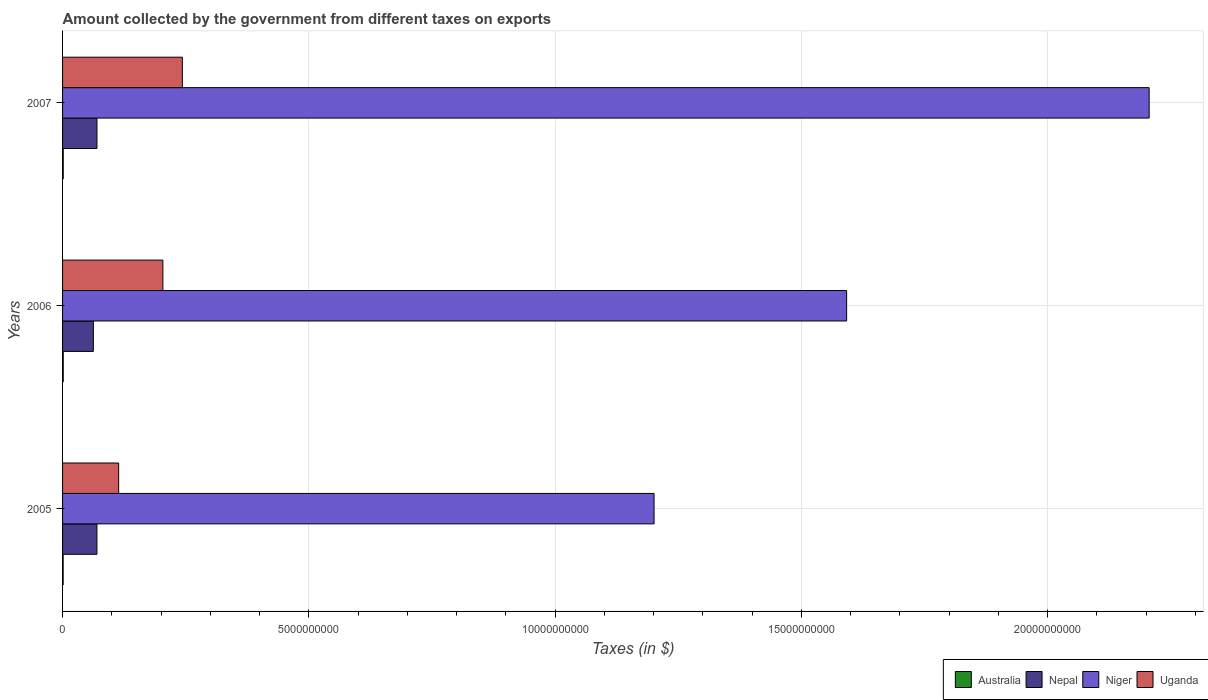How many different coloured bars are there?
Provide a short and direct response. 4. How many groups of bars are there?
Your response must be concise. 3. Are the number of bars per tick equal to the number of legend labels?
Keep it short and to the point. Yes. How many bars are there on the 3rd tick from the top?
Your answer should be compact. 4. How many bars are there on the 2nd tick from the bottom?
Provide a short and direct response. 4. What is the label of the 2nd group of bars from the top?
Your answer should be very brief. 2006. In how many cases, is the number of bars for a given year not equal to the number of legend labels?
Keep it short and to the point. 0. What is the amount collected by the government from taxes on exports in Uganda in 2007?
Offer a very short reply. 2.43e+09. Across all years, what is the maximum amount collected by the government from taxes on exports in Niger?
Your answer should be very brief. 2.21e+1. Across all years, what is the minimum amount collected by the government from taxes on exports in Nepal?
Your response must be concise. 6.25e+08. In which year was the amount collected by the government from taxes on exports in Nepal minimum?
Offer a terse response. 2006. What is the total amount collected by the government from taxes on exports in Australia in the graph?
Your response must be concise. 4.00e+07. What is the difference between the amount collected by the government from taxes on exports in Australia in 2006 and the amount collected by the government from taxes on exports in Niger in 2007?
Offer a very short reply. -2.20e+1. What is the average amount collected by the government from taxes on exports in Nepal per year?
Your answer should be very brief. 6.74e+08. In the year 2007, what is the difference between the amount collected by the government from taxes on exports in Uganda and amount collected by the government from taxes on exports in Niger?
Keep it short and to the point. -1.96e+1. What is the ratio of the amount collected by the government from taxes on exports in Nepal in 2005 to that in 2006?
Provide a short and direct response. 1.12. Is the amount collected by the government from taxes on exports in Australia in 2006 less than that in 2007?
Your answer should be compact. No. What is the difference between the highest and the second highest amount collected by the government from taxes on exports in Niger?
Keep it short and to the point. 6.14e+09. Is it the case that in every year, the sum of the amount collected by the government from taxes on exports in Nepal and amount collected by the government from taxes on exports in Australia is greater than the sum of amount collected by the government from taxes on exports in Niger and amount collected by the government from taxes on exports in Uganda?
Keep it short and to the point. No. What does the 1st bar from the bottom in 2007 represents?
Your answer should be compact. Australia. Are all the bars in the graph horizontal?
Your response must be concise. Yes. How many years are there in the graph?
Your response must be concise. 3. Are the values on the major ticks of X-axis written in scientific E-notation?
Keep it short and to the point. No. Does the graph contain any zero values?
Provide a succinct answer. No. Where does the legend appear in the graph?
Your answer should be very brief. Bottom right. What is the title of the graph?
Keep it short and to the point. Amount collected by the government from different taxes on exports. What is the label or title of the X-axis?
Provide a succinct answer. Taxes (in $). What is the Taxes (in $) in Australia in 2005?
Ensure brevity in your answer.  1.20e+07. What is the Taxes (in $) in Nepal in 2005?
Provide a short and direct response. 6.98e+08. What is the Taxes (in $) of Niger in 2005?
Provide a short and direct response. 1.20e+1. What is the Taxes (in $) in Uganda in 2005?
Offer a terse response. 1.14e+09. What is the Taxes (in $) of Australia in 2006?
Your response must be concise. 1.40e+07. What is the Taxes (in $) of Nepal in 2006?
Your answer should be very brief. 6.25e+08. What is the Taxes (in $) in Niger in 2006?
Your answer should be compact. 1.59e+1. What is the Taxes (in $) of Uganda in 2006?
Your answer should be compact. 2.04e+09. What is the Taxes (in $) in Australia in 2007?
Provide a short and direct response. 1.40e+07. What is the Taxes (in $) in Nepal in 2007?
Your response must be concise. 6.99e+08. What is the Taxes (in $) of Niger in 2007?
Make the answer very short. 2.21e+1. What is the Taxes (in $) in Uganda in 2007?
Offer a terse response. 2.43e+09. Across all years, what is the maximum Taxes (in $) in Australia?
Keep it short and to the point. 1.40e+07. Across all years, what is the maximum Taxes (in $) of Nepal?
Ensure brevity in your answer.  6.99e+08. Across all years, what is the maximum Taxes (in $) of Niger?
Offer a terse response. 2.21e+1. Across all years, what is the maximum Taxes (in $) of Uganda?
Offer a very short reply. 2.43e+09. Across all years, what is the minimum Taxes (in $) in Australia?
Provide a succinct answer. 1.20e+07. Across all years, what is the minimum Taxes (in $) of Nepal?
Your answer should be very brief. 6.25e+08. Across all years, what is the minimum Taxes (in $) of Niger?
Offer a very short reply. 1.20e+1. Across all years, what is the minimum Taxes (in $) in Uganda?
Ensure brevity in your answer.  1.14e+09. What is the total Taxes (in $) of Australia in the graph?
Your response must be concise. 4.00e+07. What is the total Taxes (in $) of Nepal in the graph?
Offer a terse response. 2.02e+09. What is the total Taxes (in $) of Niger in the graph?
Offer a terse response. 5.00e+1. What is the total Taxes (in $) of Uganda in the graph?
Keep it short and to the point. 5.61e+09. What is the difference between the Taxes (in $) of Australia in 2005 and that in 2006?
Give a very brief answer. -2.00e+06. What is the difference between the Taxes (in $) in Nepal in 2005 and that in 2006?
Your answer should be compact. 7.26e+07. What is the difference between the Taxes (in $) in Niger in 2005 and that in 2006?
Keep it short and to the point. -3.91e+09. What is the difference between the Taxes (in $) in Uganda in 2005 and that in 2006?
Your answer should be compact. -8.98e+08. What is the difference between the Taxes (in $) of Nepal in 2005 and that in 2007?
Provide a short and direct response. -7.00e+05. What is the difference between the Taxes (in $) of Niger in 2005 and that in 2007?
Provide a succinct answer. -1.01e+1. What is the difference between the Taxes (in $) of Uganda in 2005 and that in 2007?
Offer a terse response. -1.29e+09. What is the difference between the Taxes (in $) in Nepal in 2006 and that in 2007?
Offer a terse response. -7.33e+07. What is the difference between the Taxes (in $) of Niger in 2006 and that in 2007?
Offer a very short reply. -6.14e+09. What is the difference between the Taxes (in $) in Uganda in 2006 and that in 2007?
Offer a terse response. -3.95e+08. What is the difference between the Taxes (in $) in Australia in 2005 and the Taxes (in $) in Nepal in 2006?
Your answer should be compact. -6.13e+08. What is the difference between the Taxes (in $) in Australia in 2005 and the Taxes (in $) in Niger in 2006?
Your answer should be compact. -1.59e+1. What is the difference between the Taxes (in $) in Australia in 2005 and the Taxes (in $) in Uganda in 2006?
Give a very brief answer. -2.03e+09. What is the difference between the Taxes (in $) in Nepal in 2005 and the Taxes (in $) in Niger in 2006?
Make the answer very short. -1.52e+1. What is the difference between the Taxes (in $) of Nepal in 2005 and the Taxes (in $) of Uganda in 2006?
Provide a succinct answer. -1.34e+09. What is the difference between the Taxes (in $) of Niger in 2005 and the Taxes (in $) of Uganda in 2006?
Your answer should be compact. 9.97e+09. What is the difference between the Taxes (in $) in Australia in 2005 and the Taxes (in $) in Nepal in 2007?
Make the answer very short. -6.87e+08. What is the difference between the Taxes (in $) in Australia in 2005 and the Taxes (in $) in Niger in 2007?
Give a very brief answer. -2.21e+1. What is the difference between the Taxes (in $) of Australia in 2005 and the Taxes (in $) of Uganda in 2007?
Provide a short and direct response. -2.42e+09. What is the difference between the Taxes (in $) of Nepal in 2005 and the Taxes (in $) of Niger in 2007?
Your answer should be very brief. -2.14e+1. What is the difference between the Taxes (in $) in Nepal in 2005 and the Taxes (in $) in Uganda in 2007?
Give a very brief answer. -1.73e+09. What is the difference between the Taxes (in $) of Niger in 2005 and the Taxes (in $) of Uganda in 2007?
Provide a succinct answer. 9.58e+09. What is the difference between the Taxes (in $) of Australia in 2006 and the Taxes (in $) of Nepal in 2007?
Provide a short and direct response. -6.85e+08. What is the difference between the Taxes (in $) in Australia in 2006 and the Taxes (in $) in Niger in 2007?
Make the answer very short. -2.20e+1. What is the difference between the Taxes (in $) of Australia in 2006 and the Taxes (in $) of Uganda in 2007?
Ensure brevity in your answer.  -2.42e+09. What is the difference between the Taxes (in $) in Nepal in 2006 and the Taxes (in $) in Niger in 2007?
Make the answer very short. -2.14e+1. What is the difference between the Taxes (in $) of Nepal in 2006 and the Taxes (in $) of Uganda in 2007?
Provide a short and direct response. -1.81e+09. What is the difference between the Taxes (in $) in Niger in 2006 and the Taxes (in $) in Uganda in 2007?
Keep it short and to the point. 1.35e+1. What is the average Taxes (in $) in Australia per year?
Provide a succinct answer. 1.33e+07. What is the average Taxes (in $) in Nepal per year?
Keep it short and to the point. 6.74e+08. What is the average Taxes (in $) in Niger per year?
Make the answer very short. 1.67e+1. What is the average Taxes (in $) in Uganda per year?
Your response must be concise. 1.87e+09. In the year 2005, what is the difference between the Taxes (in $) of Australia and Taxes (in $) of Nepal?
Keep it short and to the point. -6.86e+08. In the year 2005, what is the difference between the Taxes (in $) of Australia and Taxes (in $) of Niger?
Provide a short and direct response. -1.20e+1. In the year 2005, what is the difference between the Taxes (in $) in Australia and Taxes (in $) in Uganda?
Keep it short and to the point. -1.13e+09. In the year 2005, what is the difference between the Taxes (in $) in Nepal and Taxes (in $) in Niger?
Provide a succinct answer. -1.13e+1. In the year 2005, what is the difference between the Taxes (in $) of Nepal and Taxes (in $) of Uganda?
Keep it short and to the point. -4.41e+08. In the year 2005, what is the difference between the Taxes (in $) of Niger and Taxes (in $) of Uganda?
Give a very brief answer. 1.09e+1. In the year 2006, what is the difference between the Taxes (in $) of Australia and Taxes (in $) of Nepal?
Ensure brevity in your answer.  -6.11e+08. In the year 2006, what is the difference between the Taxes (in $) in Australia and Taxes (in $) in Niger?
Give a very brief answer. -1.59e+1. In the year 2006, what is the difference between the Taxes (in $) of Australia and Taxes (in $) of Uganda?
Make the answer very short. -2.02e+09. In the year 2006, what is the difference between the Taxes (in $) in Nepal and Taxes (in $) in Niger?
Your answer should be very brief. -1.53e+1. In the year 2006, what is the difference between the Taxes (in $) of Nepal and Taxes (in $) of Uganda?
Make the answer very short. -1.41e+09. In the year 2006, what is the difference between the Taxes (in $) in Niger and Taxes (in $) in Uganda?
Keep it short and to the point. 1.39e+1. In the year 2007, what is the difference between the Taxes (in $) in Australia and Taxes (in $) in Nepal?
Provide a succinct answer. -6.85e+08. In the year 2007, what is the difference between the Taxes (in $) of Australia and Taxes (in $) of Niger?
Give a very brief answer. -2.20e+1. In the year 2007, what is the difference between the Taxes (in $) in Australia and Taxes (in $) in Uganda?
Your answer should be compact. -2.42e+09. In the year 2007, what is the difference between the Taxes (in $) in Nepal and Taxes (in $) in Niger?
Keep it short and to the point. -2.14e+1. In the year 2007, what is the difference between the Taxes (in $) in Nepal and Taxes (in $) in Uganda?
Make the answer very short. -1.73e+09. In the year 2007, what is the difference between the Taxes (in $) of Niger and Taxes (in $) of Uganda?
Your response must be concise. 1.96e+1. What is the ratio of the Taxes (in $) in Nepal in 2005 to that in 2006?
Your answer should be very brief. 1.12. What is the ratio of the Taxes (in $) in Niger in 2005 to that in 2006?
Keep it short and to the point. 0.75. What is the ratio of the Taxes (in $) in Uganda in 2005 to that in 2006?
Ensure brevity in your answer.  0.56. What is the ratio of the Taxes (in $) in Nepal in 2005 to that in 2007?
Provide a short and direct response. 1. What is the ratio of the Taxes (in $) in Niger in 2005 to that in 2007?
Your response must be concise. 0.54. What is the ratio of the Taxes (in $) of Uganda in 2005 to that in 2007?
Offer a terse response. 0.47. What is the ratio of the Taxes (in $) of Australia in 2006 to that in 2007?
Make the answer very short. 1. What is the ratio of the Taxes (in $) of Nepal in 2006 to that in 2007?
Offer a very short reply. 0.9. What is the ratio of the Taxes (in $) of Niger in 2006 to that in 2007?
Keep it short and to the point. 0.72. What is the ratio of the Taxes (in $) in Uganda in 2006 to that in 2007?
Offer a very short reply. 0.84. What is the difference between the highest and the second highest Taxes (in $) of Australia?
Your response must be concise. 0. What is the difference between the highest and the second highest Taxes (in $) of Nepal?
Offer a very short reply. 7.00e+05. What is the difference between the highest and the second highest Taxes (in $) in Niger?
Ensure brevity in your answer.  6.14e+09. What is the difference between the highest and the second highest Taxes (in $) of Uganda?
Ensure brevity in your answer.  3.95e+08. What is the difference between the highest and the lowest Taxes (in $) of Australia?
Provide a short and direct response. 2.00e+06. What is the difference between the highest and the lowest Taxes (in $) in Nepal?
Your response must be concise. 7.33e+07. What is the difference between the highest and the lowest Taxes (in $) in Niger?
Give a very brief answer. 1.01e+1. What is the difference between the highest and the lowest Taxes (in $) of Uganda?
Your answer should be very brief. 1.29e+09. 